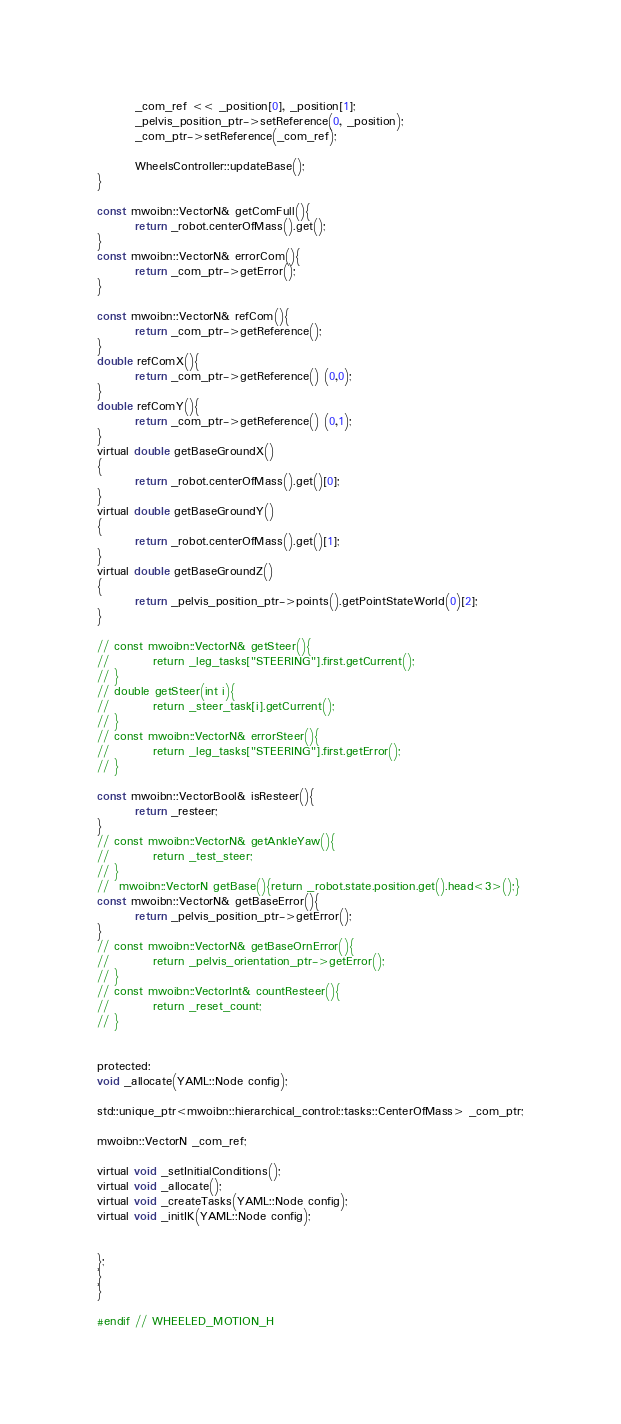Convert code to text. <code><loc_0><loc_0><loc_500><loc_500><_C_>
        _com_ref << _position[0], _position[1];
        _pelvis_position_ptr->setReference(0, _position);
        _com_ptr->setReference(_com_ref);

        WheelsController::updateBase();
}

const mwoibn::VectorN& getComFull(){
        return _robot.centerOfMass().get();
}
const mwoibn::VectorN& errorCom(){
        return _com_ptr->getError();
}

const mwoibn::VectorN& refCom(){
        return _com_ptr->getReference();
}
double refComX(){
        return _com_ptr->getReference() (0,0);
}
double refComY(){
        return _com_ptr->getReference() (0,1);
}
virtual double getBaseGroundX()
{
        return _robot.centerOfMass().get()[0];
}
virtual double getBaseGroundY()
{
        return _robot.centerOfMass().get()[1];
}
virtual double getBaseGroundZ()
{
        return _pelvis_position_ptr->points().getPointStateWorld(0)[2];
}

// const mwoibn::VectorN& getSteer(){
//         return _leg_tasks["STEERING"].first.getCurrent();
// }
// double getSteer(int i){
//         return _steer_task[i].getCurrent();
// }
// const mwoibn::VectorN& errorSteer(){
//         return _leg_tasks["STEERING"].first.getError();
// }

const mwoibn::VectorBool& isResteer(){
        return _resteer;
}
// const mwoibn::VectorN& getAnkleYaw(){
//         return _test_steer;
// }
//  mwoibn::VectorN getBase(){return _robot.state.position.get().head<3>();}
const mwoibn::VectorN& getBaseError(){
        return _pelvis_position_ptr->getError();
}
// const mwoibn::VectorN& getBaseOrnError(){
//         return _pelvis_orientation_ptr->getError();
// }
// const mwoibn::VectorInt& countResteer(){
//         return _reset_count;
// }


protected:
void _allocate(YAML::Node config);

std::unique_ptr<mwoibn::hierarchical_control::tasks::CenterOfMass> _com_ptr;

mwoibn::VectorN _com_ref;

virtual void _setInitialConditions();
virtual void _allocate();
virtual void _createTasks(YAML::Node config);
virtual void _initIK(YAML::Node config);


};
}
}

#endif // WHEELED_MOTION_H
</code> 